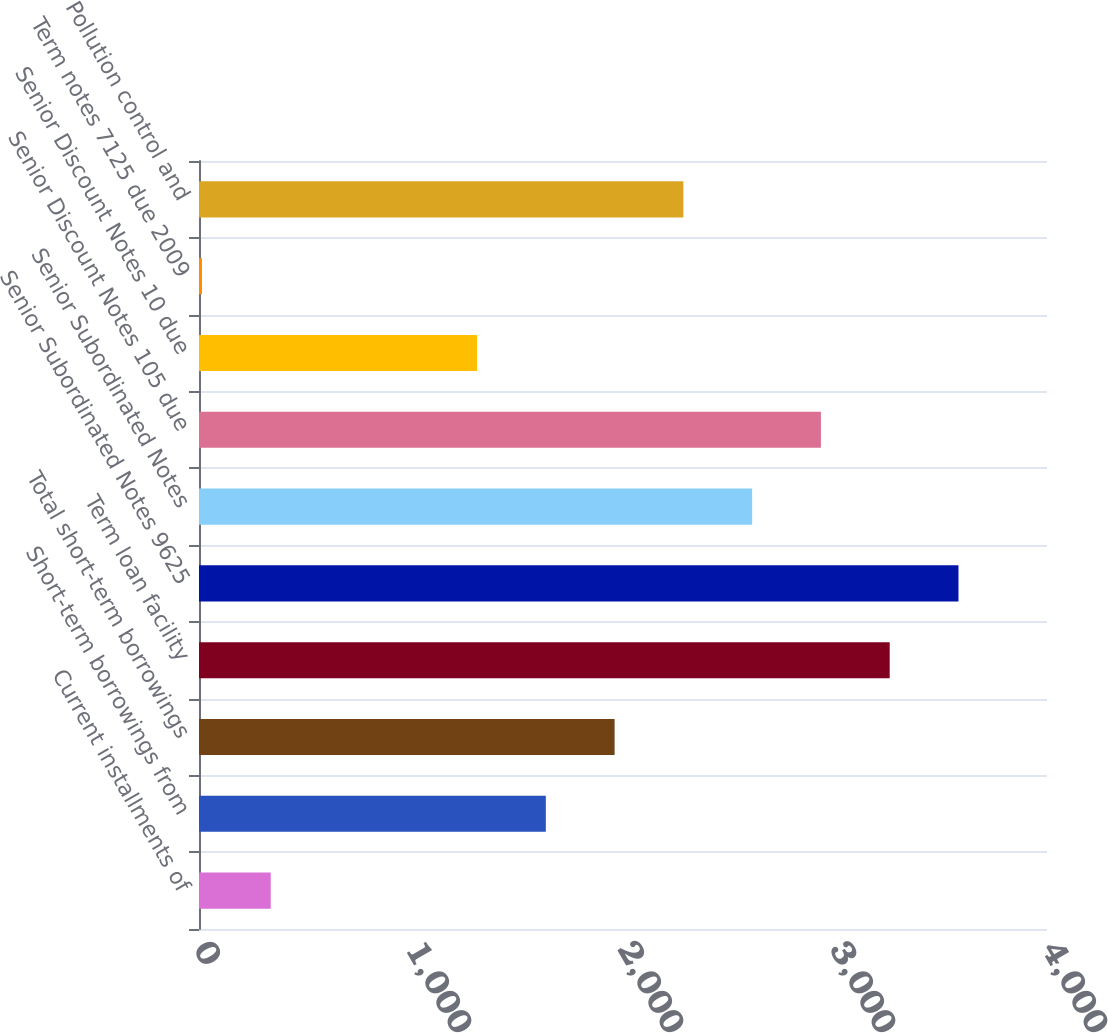Convert chart to OTSL. <chart><loc_0><loc_0><loc_500><loc_500><bar_chart><fcel>Current installments of<fcel>Short-term borrowings from<fcel>Total short-term borrowings<fcel>Term loan facility<fcel>Senior Subordinated Notes 9625<fcel>Senior Subordinated Notes<fcel>Senior Discount Notes 105 due<fcel>Senior Discount Notes 10 due<fcel>Term notes 7125 due 2009<fcel>Pollution control and<nl><fcel>338.4<fcel>1636<fcel>1960.4<fcel>3258<fcel>3582.4<fcel>2609.2<fcel>2933.6<fcel>1311.6<fcel>14<fcel>2284.8<nl></chart> 